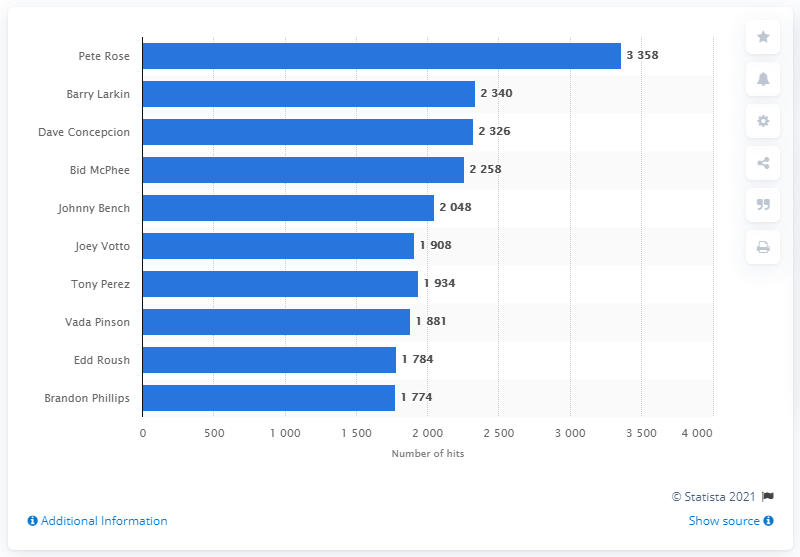Highlight a few significant elements in this photo. The individual who has recorded the most hits in the history of the Cincinnati Reds franchise is Pete Rose. 